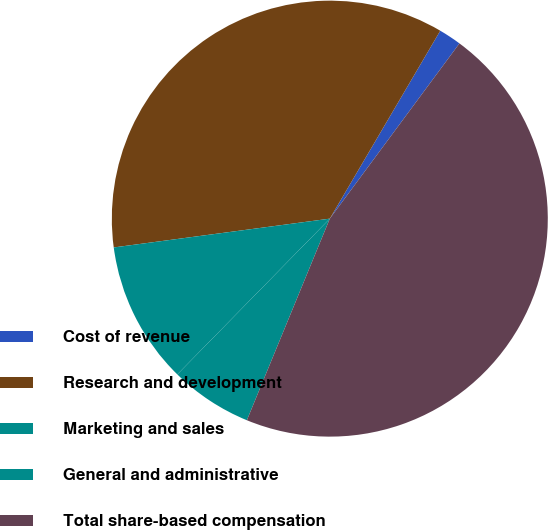Convert chart to OTSL. <chart><loc_0><loc_0><loc_500><loc_500><pie_chart><fcel>Cost of revenue<fcel>Research and development<fcel>Marketing and sales<fcel>General and administrative<fcel>Total share-based compensation<nl><fcel>1.68%<fcel>35.57%<fcel>10.56%<fcel>6.12%<fcel>46.08%<nl></chart> 